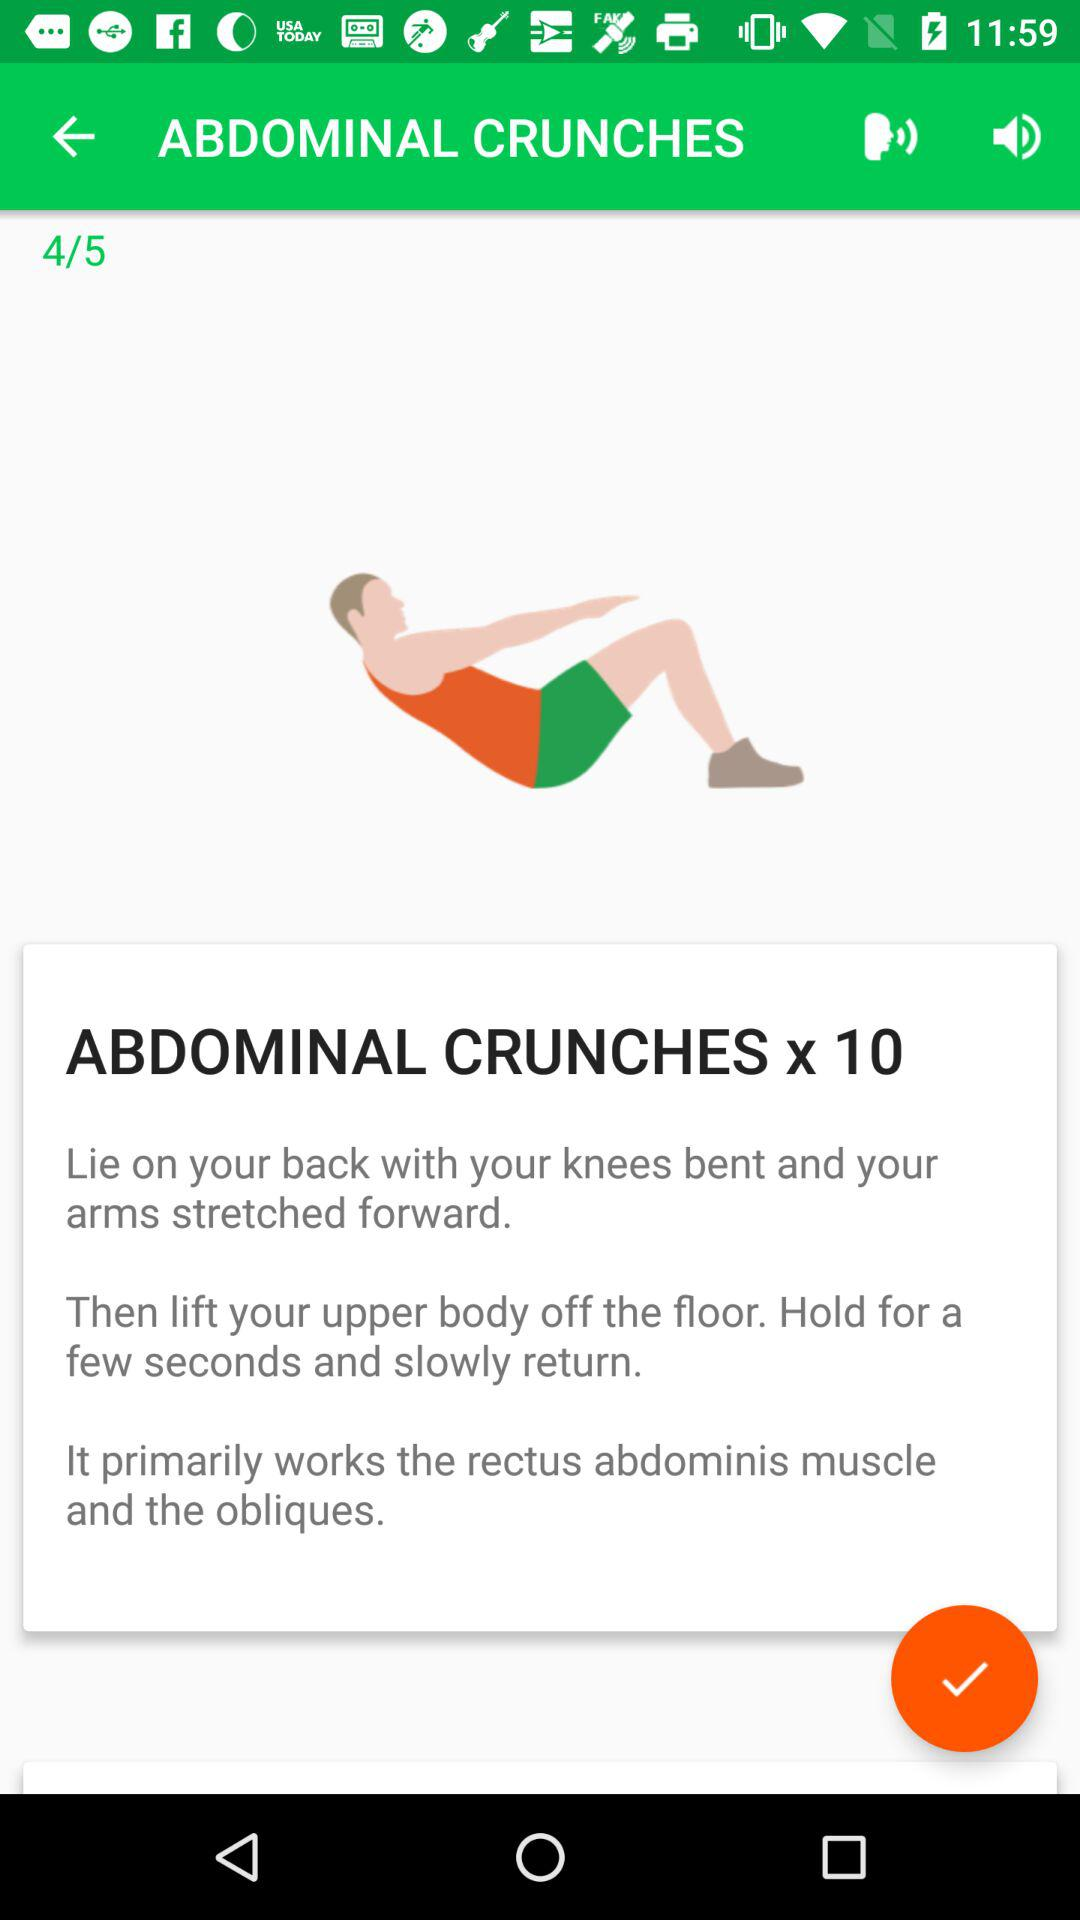How many more sets do I have to do?
Answer the question using a single word or phrase. 1 